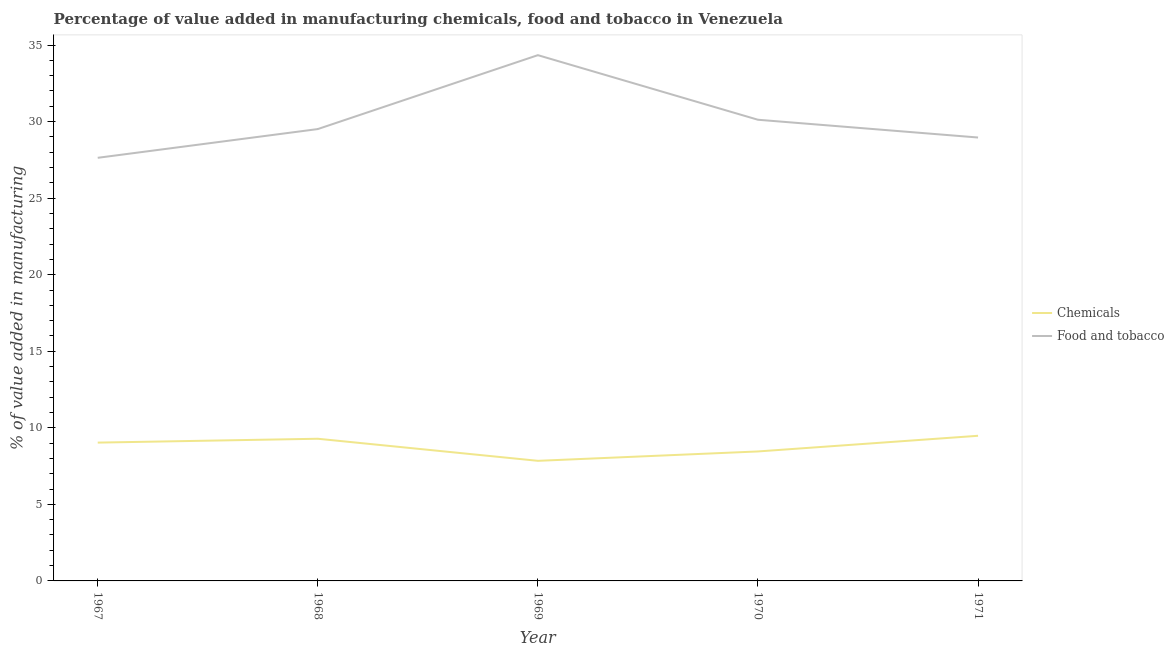Does the line corresponding to value added by manufacturing food and tobacco intersect with the line corresponding to value added by  manufacturing chemicals?
Ensure brevity in your answer.  No. Is the number of lines equal to the number of legend labels?
Ensure brevity in your answer.  Yes. What is the value added by manufacturing food and tobacco in 1970?
Keep it short and to the point. 30.12. Across all years, what is the maximum value added by manufacturing food and tobacco?
Ensure brevity in your answer.  34.34. Across all years, what is the minimum value added by  manufacturing chemicals?
Provide a short and direct response. 7.84. In which year was the value added by manufacturing food and tobacco minimum?
Your response must be concise. 1967. What is the total value added by manufacturing food and tobacco in the graph?
Your response must be concise. 150.57. What is the difference between the value added by  manufacturing chemicals in 1967 and that in 1968?
Provide a short and direct response. -0.25. What is the difference between the value added by  manufacturing chemicals in 1968 and the value added by manufacturing food and tobacco in 1967?
Offer a terse response. -18.35. What is the average value added by manufacturing food and tobacco per year?
Make the answer very short. 30.11. In the year 1971, what is the difference between the value added by  manufacturing chemicals and value added by manufacturing food and tobacco?
Your answer should be compact. -19.48. What is the ratio of the value added by  manufacturing chemicals in 1968 to that in 1970?
Offer a terse response. 1.1. Is the value added by  manufacturing chemicals in 1969 less than that in 1970?
Provide a succinct answer. Yes. What is the difference between the highest and the second highest value added by  manufacturing chemicals?
Provide a succinct answer. 0.19. What is the difference between the highest and the lowest value added by manufacturing food and tobacco?
Ensure brevity in your answer.  6.7. Is the sum of the value added by  manufacturing chemicals in 1968 and 1969 greater than the maximum value added by manufacturing food and tobacco across all years?
Your answer should be very brief. No. Is the value added by  manufacturing chemicals strictly greater than the value added by manufacturing food and tobacco over the years?
Your response must be concise. No. Is the value added by  manufacturing chemicals strictly less than the value added by manufacturing food and tobacco over the years?
Provide a succinct answer. Yes. How many lines are there?
Give a very brief answer. 2. What is the difference between two consecutive major ticks on the Y-axis?
Give a very brief answer. 5. Are the values on the major ticks of Y-axis written in scientific E-notation?
Provide a short and direct response. No. Does the graph contain any zero values?
Provide a succinct answer. No. How are the legend labels stacked?
Give a very brief answer. Vertical. What is the title of the graph?
Ensure brevity in your answer.  Percentage of value added in manufacturing chemicals, food and tobacco in Venezuela. What is the label or title of the Y-axis?
Give a very brief answer. % of value added in manufacturing. What is the % of value added in manufacturing in Chemicals in 1967?
Make the answer very short. 9.03. What is the % of value added in manufacturing of Food and tobacco in 1967?
Make the answer very short. 27.64. What is the % of value added in manufacturing of Chemicals in 1968?
Provide a short and direct response. 9.29. What is the % of value added in manufacturing of Food and tobacco in 1968?
Provide a short and direct response. 29.51. What is the % of value added in manufacturing in Chemicals in 1969?
Make the answer very short. 7.84. What is the % of value added in manufacturing in Food and tobacco in 1969?
Give a very brief answer. 34.34. What is the % of value added in manufacturing of Chemicals in 1970?
Keep it short and to the point. 8.46. What is the % of value added in manufacturing in Food and tobacco in 1970?
Make the answer very short. 30.12. What is the % of value added in manufacturing of Chemicals in 1971?
Provide a short and direct response. 9.48. What is the % of value added in manufacturing in Food and tobacco in 1971?
Provide a short and direct response. 28.96. Across all years, what is the maximum % of value added in manufacturing in Chemicals?
Provide a short and direct response. 9.48. Across all years, what is the maximum % of value added in manufacturing of Food and tobacco?
Offer a very short reply. 34.34. Across all years, what is the minimum % of value added in manufacturing of Chemicals?
Give a very brief answer. 7.84. Across all years, what is the minimum % of value added in manufacturing in Food and tobacco?
Offer a terse response. 27.64. What is the total % of value added in manufacturing of Chemicals in the graph?
Give a very brief answer. 44.1. What is the total % of value added in manufacturing of Food and tobacco in the graph?
Offer a terse response. 150.57. What is the difference between the % of value added in manufacturing of Chemicals in 1967 and that in 1968?
Offer a terse response. -0.25. What is the difference between the % of value added in manufacturing in Food and tobacco in 1967 and that in 1968?
Keep it short and to the point. -1.88. What is the difference between the % of value added in manufacturing of Chemicals in 1967 and that in 1969?
Provide a succinct answer. 1.19. What is the difference between the % of value added in manufacturing in Food and tobacco in 1967 and that in 1969?
Ensure brevity in your answer.  -6.7. What is the difference between the % of value added in manufacturing of Chemicals in 1967 and that in 1970?
Provide a succinct answer. 0.58. What is the difference between the % of value added in manufacturing of Food and tobacco in 1967 and that in 1970?
Offer a very short reply. -2.48. What is the difference between the % of value added in manufacturing in Chemicals in 1967 and that in 1971?
Your response must be concise. -0.45. What is the difference between the % of value added in manufacturing in Food and tobacco in 1967 and that in 1971?
Ensure brevity in your answer.  -1.32. What is the difference between the % of value added in manufacturing in Chemicals in 1968 and that in 1969?
Provide a short and direct response. 1.44. What is the difference between the % of value added in manufacturing of Food and tobacco in 1968 and that in 1969?
Provide a short and direct response. -4.83. What is the difference between the % of value added in manufacturing in Chemicals in 1968 and that in 1970?
Keep it short and to the point. 0.83. What is the difference between the % of value added in manufacturing of Food and tobacco in 1968 and that in 1970?
Provide a succinct answer. -0.61. What is the difference between the % of value added in manufacturing of Chemicals in 1968 and that in 1971?
Offer a terse response. -0.19. What is the difference between the % of value added in manufacturing of Food and tobacco in 1968 and that in 1971?
Provide a short and direct response. 0.55. What is the difference between the % of value added in manufacturing of Chemicals in 1969 and that in 1970?
Your response must be concise. -0.61. What is the difference between the % of value added in manufacturing of Food and tobacco in 1969 and that in 1970?
Keep it short and to the point. 4.22. What is the difference between the % of value added in manufacturing of Chemicals in 1969 and that in 1971?
Ensure brevity in your answer.  -1.64. What is the difference between the % of value added in manufacturing in Food and tobacco in 1969 and that in 1971?
Your response must be concise. 5.38. What is the difference between the % of value added in manufacturing of Chemicals in 1970 and that in 1971?
Your response must be concise. -1.02. What is the difference between the % of value added in manufacturing of Food and tobacco in 1970 and that in 1971?
Ensure brevity in your answer.  1.16. What is the difference between the % of value added in manufacturing in Chemicals in 1967 and the % of value added in manufacturing in Food and tobacco in 1968?
Ensure brevity in your answer.  -20.48. What is the difference between the % of value added in manufacturing in Chemicals in 1967 and the % of value added in manufacturing in Food and tobacco in 1969?
Your answer should be compact. -25.31. What is the difference between the % of value added in manufacturing of Chemicals in 1967 and the % of value added in manufacturing of Food and tobacco in 1970?
Provide a succinct answer. -21.09. What is the difference between the % of value added in manufacturing of Chemicals in 1967 and the % of value added in manufacturing of Food and tobacco in 1971?
Ensure brevity in your answer.  -19.93. What is the difference between the % of value added in manufacturing in Chemicals in 1968 and the % of value added in manufacturing in Food and tobacco in 1969?
Make the answer very short. -25.05. What is the difference between the % of value added in manufacturing in Chemicals in 1968 and the % of value added in manufacturing in Food and tobacco in 1970?
Your answer should be very brief. -20.83. What is the difference between the % of value added in manufacturing in Chemicals in 1968 and the % of value added in manufacturing in Food and tobacco in 1971?
Your answer should be compact. -19.67. What is the difference between the % of value added in manufacturing in Chemicals in 1969 and the % of value added in manufacturing in Food and tobacco in 1970?
Provide a succinct answer. -22.28. What is the difference between the % of value added in manufacturing in Chemicals in 1969 and the % of value added in manufacturing in Food and tobacco in 1971?
Give a very brief answer. -21.12. What is the difference between the % of value added in manufacturing in Chemicals in 1970 and the % of value added in manufacturing in Food and tobacco in 1971?
Your response must be concise. -20.5. What is the average % of value added in manufacturing of Chemicals per year?
Offer a very short reply. 8.82. What is the average % of value added in manufacturing of Food and tobacco per year?
Your response must be concise. 30.11. In the year 1967, what is the difference between the % of value added in manufacturing in Chemicals and % of value added in manufacturing in Food and tobacco?
Your answer should be compact. -18.6. In the year 1968, what is the difference between the % of value added in manufacturing in Chemicals and % of value added in manufacturing in Food and tobacco?
Offer a very short reply. -20.23. In the year 1969, what is the difference between the % of value added in manufacturing in Chemicals and % of value added in manufacturing in Food and tobacco?
Your response must be concise. -26.5. In the year 1970, what is the difference between the % of value added in manufacturing in Chemicals and % of value added in manufacturing in Food and tobacco?
Your answer should be compact. -21.66. In the year 1971, what is the difference between the % of value added in manufacturing in Chemicals and % of value added in manufacturing in Food and tobacco?
Your response must be concise. -19.48. What is the ratio of the % of value added in manufacturing of Chemicals in 1967 to that in 1968?
Your answer should be very brief. 0.97. What is the ratio of the % of value added in manufacturing of Food and tobacco in 1967 to that in 1968?
Your response must be concise. 0.94. What is the ratio of the % of value added in manufacturing of Chemicals in 1967 to that in 1969?
Provide a short and direct response. 1.15. What is the ratio of the % of value added in manufacturing in Food and tobacco in 1967 to that in 1969?
Offer a terse response. 0.8. What is the ratio of the % of value added in manufacturing of Chemicals in 1967 to that in 1970?
Offer a very short reply. 1.07. What is the ratio of the % of value added in manufacturing of Food and tobacco in 1967 to that in 1970?
Keep it short and to the point. 0.92. What is the ratio of the % of value added in manufacturing in Chemicals in 1967 to that in 1971?
Your answer should be very brief. 0.95. What is the ratio of the % of value added in manufacturing in Food and tobacco in 1967 to that in 1971?
Your answer should be very brief. 0.95. What is the ratio of the % of value added in manufacturing in Chemicals in 1968 to that in 1969?
Provide a short and direct response. 1.18. What is the ratio of the % of value added in manufacturing in Food and tobacco in 1968 to that in 1969?
Keep it short and to the point. 0.86. What is the ratio of the % of value added in manufacturing of Chemicals in 1968 to that in 1970?
Offer a very short reply. 1.1. What is the ratio of the % of value added in manufacturing in Food and tobacco in 1968 to that in 1970?
Provide a succinct answer. 0.98. What is the ratio of the % of value added in manufacturing in Chemicals in 1968 to that in 1971?
Your response must be concise. 0.98. What is the ratio of the % of value added in manufacturing in Food and tobacco in 1968 to that in 1971?
Your response must be concise. 1.02. What is the ratio of the % of value added in manufacturing in Chemicals in 1969 to that in 1970?
Ensure brevity in your answer.  0.93. What is the ratio of the % of value added in manufacturing of Food and tobacco in 1969 to that in 1970?
Make the answer very short. 1.14. What is the ratio of the % of value added in manufacturing of Chemicals in 1969 to that in 1971?
Ensure brevity in your answer.  0.83. What is the ratio of the % of value added in manufacturing of Food and tobacco in 1969 to that in 1971?
Your response must be concise. 1.19. What is the ratio of the % of value added in manufacturing in Chemicals in 1970 to that in 1971?
Your answer should be compact. 0.89. What is the ratio of the % of value added in manufacturing in Food and tobacco in 1970 to that in 1971?
Keep it short and to the point. 1.04. What is the difference between the highest and the second highest % of value added in manufacturing of Chemicals?
Your answer should be compact. 0.19. What is the difference between the highest and the second highest % of value added in manufacturing in Food and tobacco?
Make the answer very short. 4.22. What is the difference between the highest and the lowest % of value added in manufacturing of Chemicals?
Provide a succinct answer. 1.64. What is the difference between the highest and the lowest % of value added in manufacturing of Food and tobacco?
Keep it short and to the point. 6.7. 